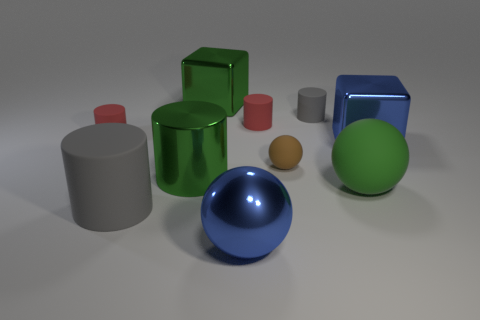Subtract all metal balls. How many balls are left? 2 Subtract all red cylinders. How many cylinders are left? 3 Subtract all balls. How many objects are left? 7 Subtract 1 blocks. How many blocks are left? 1 Subtract all cyan balls. How many purple cylinders are left? 0 Subtract all large cubes. Subtract all shiny blocks. How many objects are left? 6 Add 4 large blue cubes. How many large blue cubes are left? 5 Add 1 large gray cylinders. How many large gray cylinders exist? 2 Subtract 0 yellow spheres. How many objects are left? 10 Subtract all red cylinders. Subtract all green blocks. How many cylinders are left? 3 